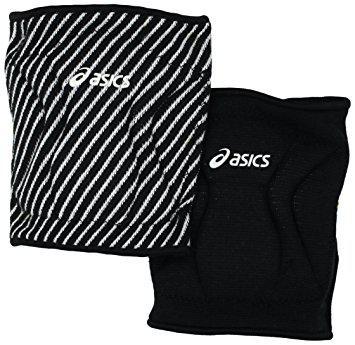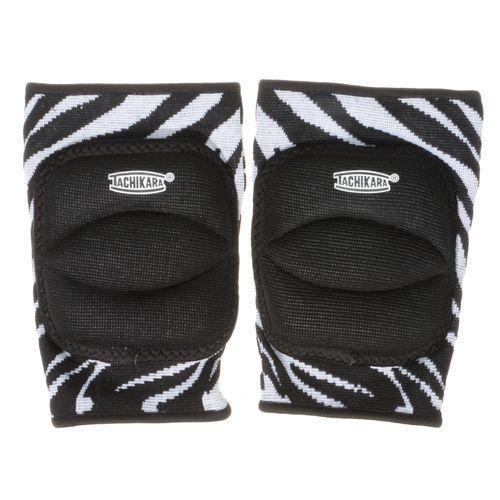The first image is the image on the left, the second image is the image on the right. For the images displayed, is the sentence "One image shows a black knee pad with a white logo and like a white knee pad with a black logo." factually correct? Answer yes or no. No. 